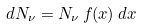Convert formula to latex. <formula><loc_0><loc_0><loc_500><loc_500>d N _ { \nu } = N _ { \nu } \, f ( x ) \, d x</formula> 